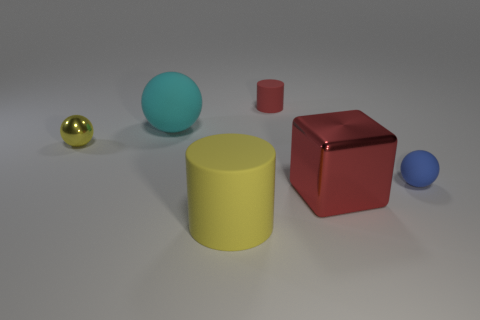There is another big sphere that is made of the same material as the blue ball; what color is it? If we are considering another large sphere made from a material similar to the one used for the blue ball shown in the image, we can surmise that its color might also be a hue related to blue but not necessarily identical. It could range from a light sky blue to a deep navy, depending on how light interacts with it and its finishing material. However, without an actual sphere to reference, we can't definitively determine its color. 